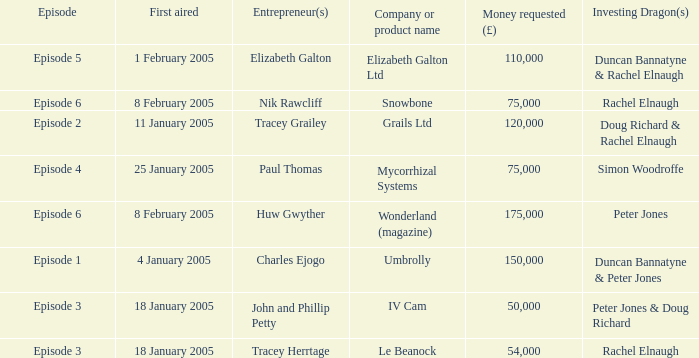What is the average money requested in the episode first aired on 18 January 2005 by the company/product name IV Cam 50000.0. 